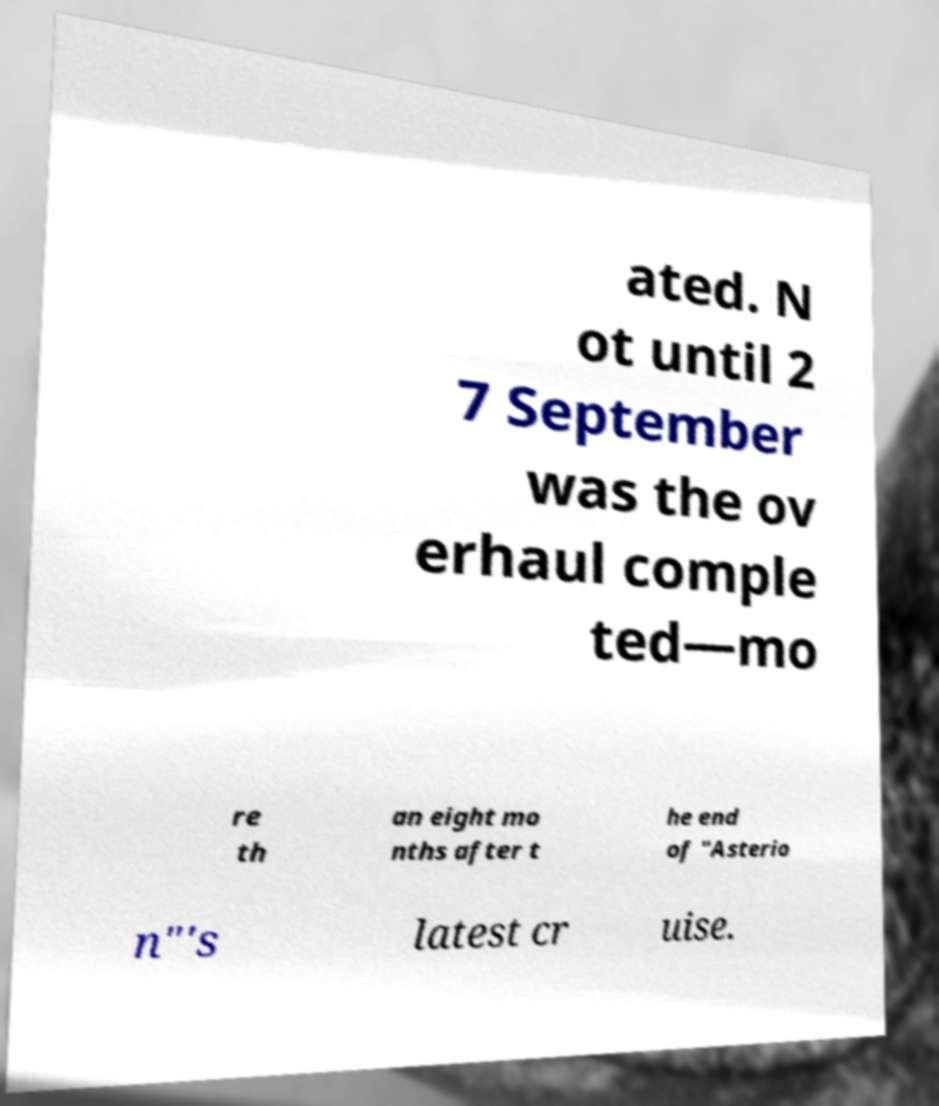What messages or text are displayed in this image? I need them in a readable, typed format. ated. N ot until 2 7 September was the ov erhaul comple ted—mo re th an eight mo nths after t he end of "Asterio n"'s latest cr uise. 